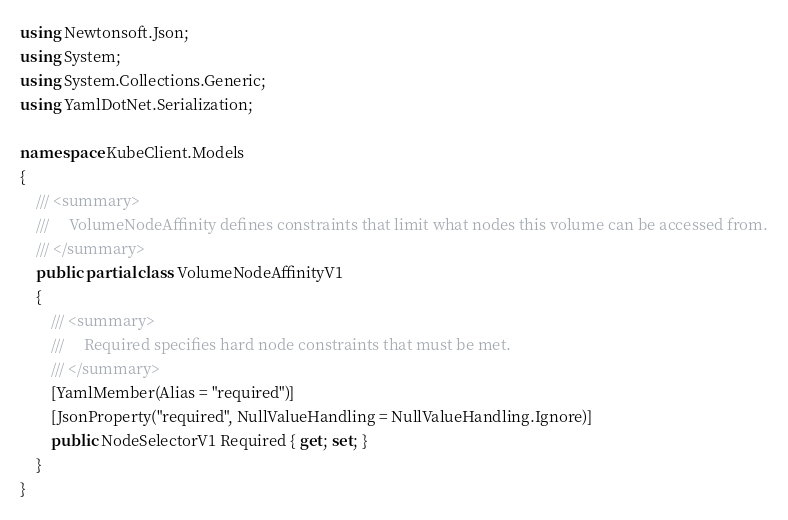Convert code to text. <code><loc_0><loc_0><loc_500><loc_500><_C#_>using Newtonsoft.Json;
using System;
using System.Collections.Generic;
using YamlDotNet.Serialization;

namespace KubeClient.Models
{
    /// <summary>
    ///     VolumeNodeAffinity defines constraints that limit what nodes this volume can be accessed from.
    /// </summary>
    public partial class VolumeNodeAffinityV1
    {
        /// <summary>
        ///     Required specifies hard node constraints that must be met.
        /// </summary>
        [YamlMember(Alias = "required")]
        [JsonProperty("required", NullValueHandling = NullValueHandling.Ignore)]
        public NodeSelectorV1 Required { get; set; }
    }
}
</code> 